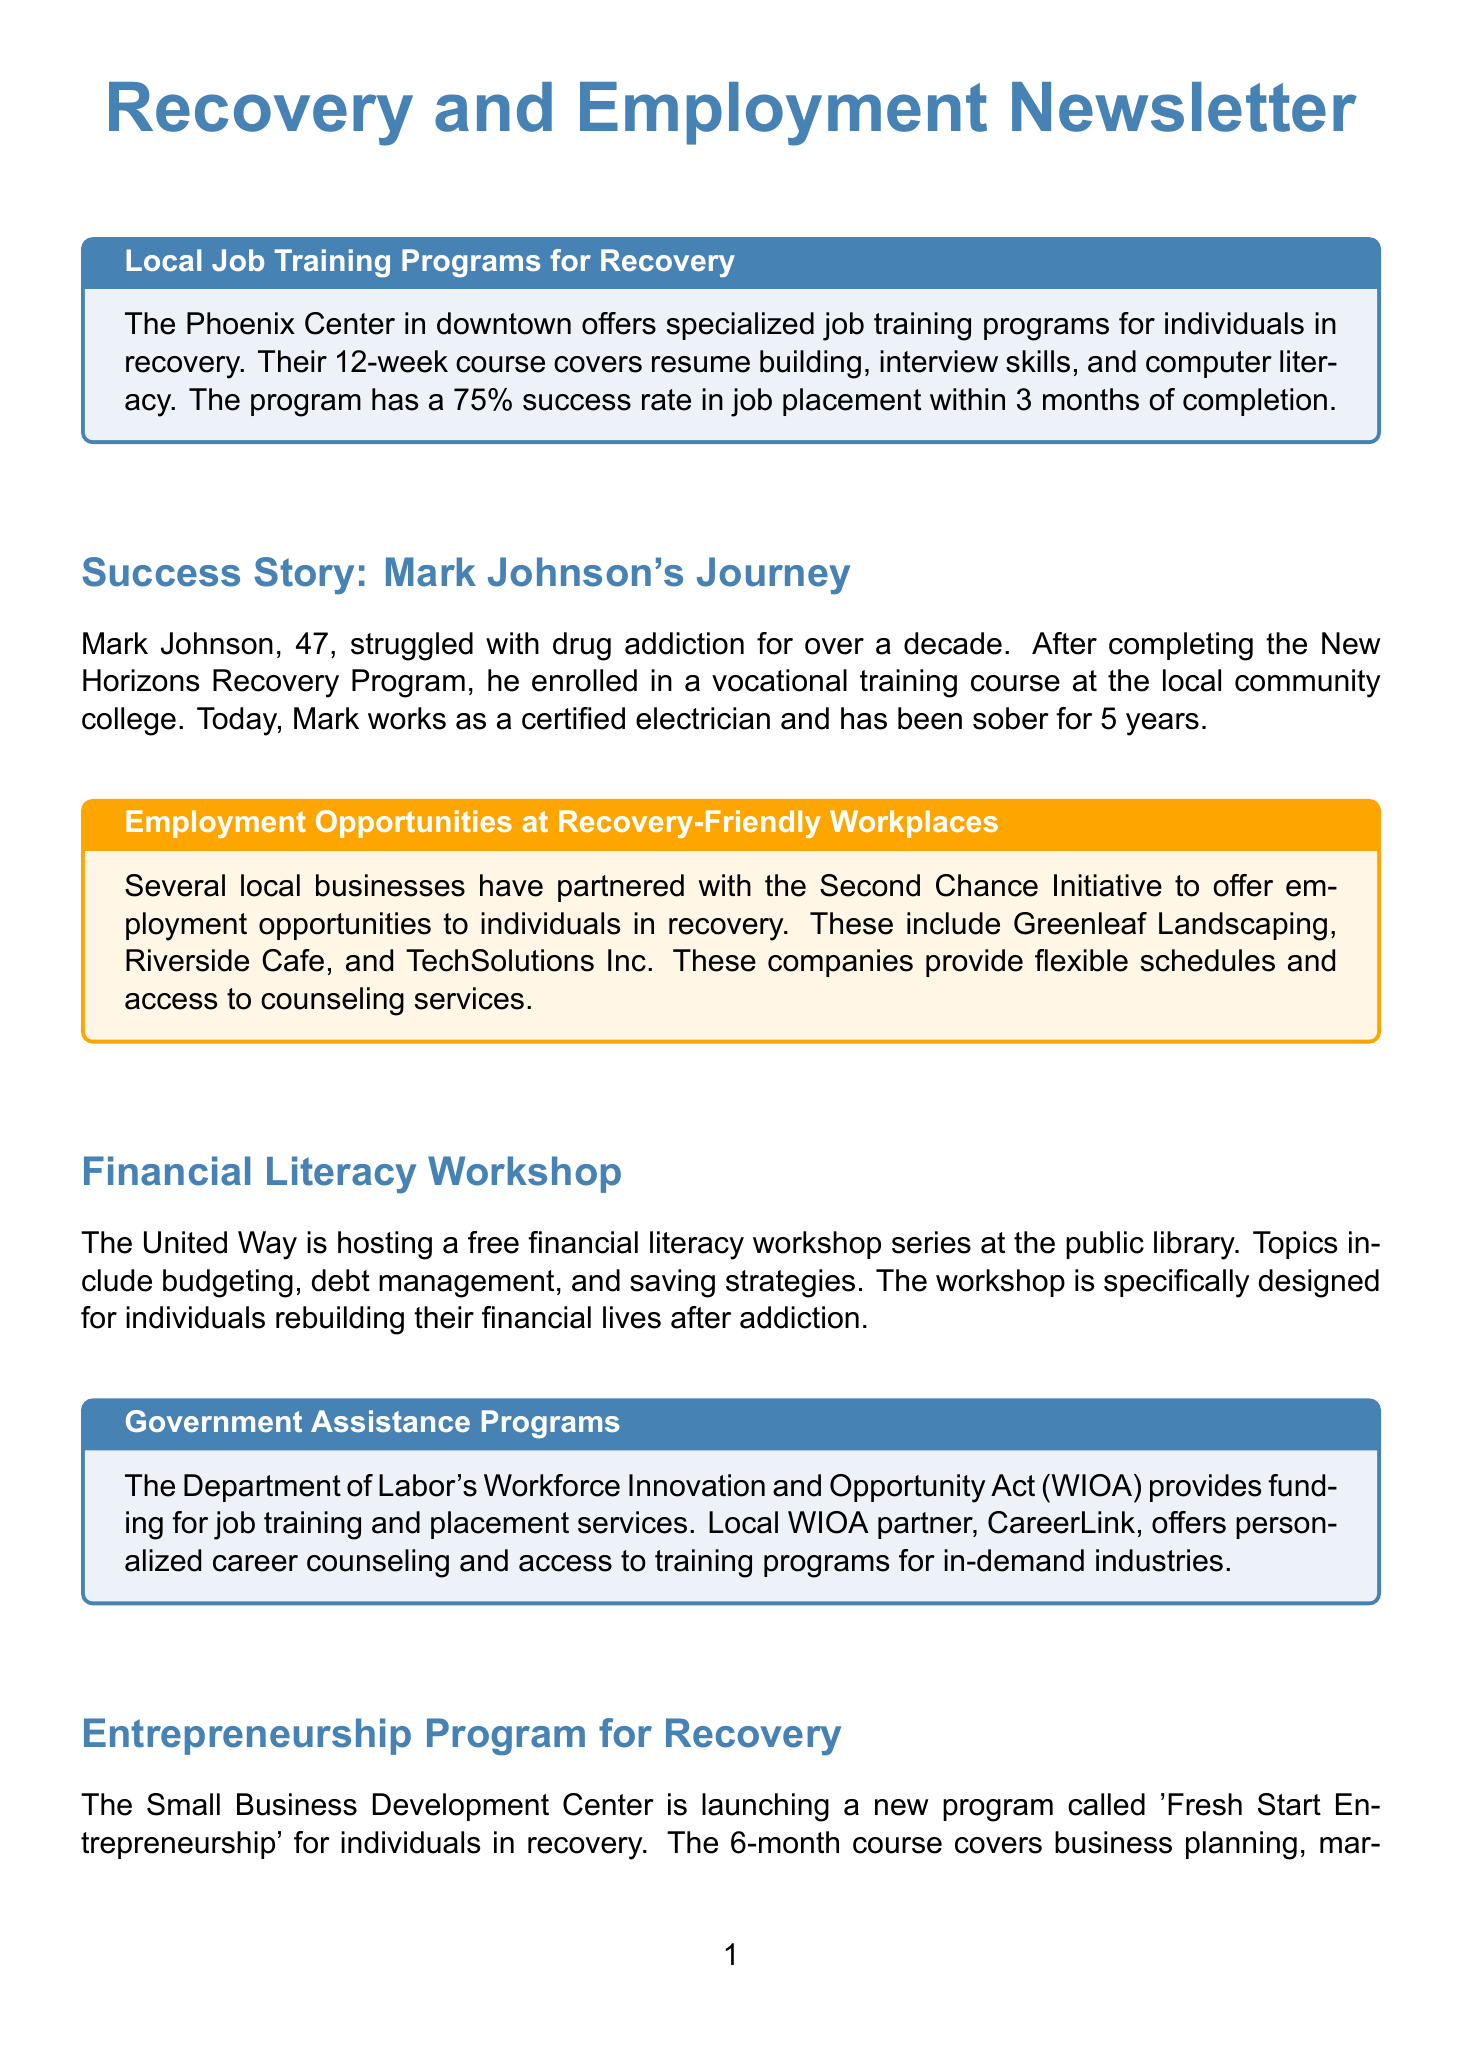what is the success rate of the Phoenix Center's job training program? The success rate of the Phoenix Center's job training program is stated as 75%.
Answer: 75% who is the success story highlighted in the newsletter? The success story highlighted in the newsletter is about Mark Johnson.
Answer: Mark Johnson how long is the financial literacy workshop series hosted by the United Way? The duration of the financial literacy workshop series is not specified in the document, but it is indicated as a series.
Answer: not specified which local initiative partners with businesses to offer job opportunities? The initiative that partners with businesses to offer job opportunities is the Second Chance Initiative.
Answer: Second Chance Initiative what is the name of the entrepreneurship program? The name of the entrepreneurship program is 'Fresh Start Entrepreneurship'.
Answer: 'Fresh Start Entrepreneurship' how many weeks does the Phoenix Center's job training course last? The Phoenix Center's job training course lasts for 12 weeks.
Answer: 12 weeks which local businesses offer employment opportunities to individuals in recovery? The local businesses offering employment opportunities include Greenleaf Landscaping, Riverside Cafe, and TechSolutions Inc.
Answer: Greenleaf Landscaping, Riverside Cafe, and TechSolutions Inc what is a feature of the employment opportunities offered by the Second Chance Initiative partners? A feature of the employment opportunities is that they provide flexible schedules.
Answer: flexible schedules 